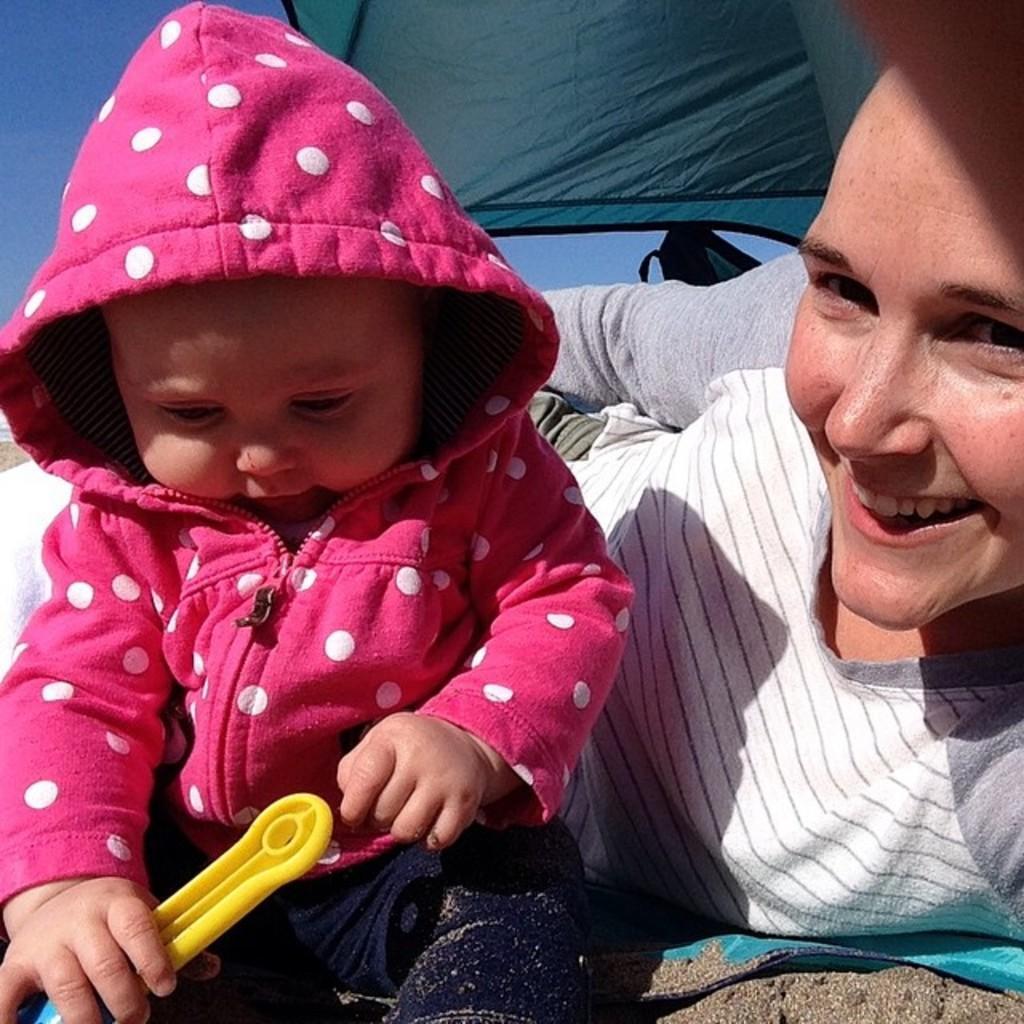Can you describe this image briefly? In this image on the right side there is a woman laying on the ground and smiling and there is a kid sitting and playing with a toy. In the background there is an object which is green in colour. 